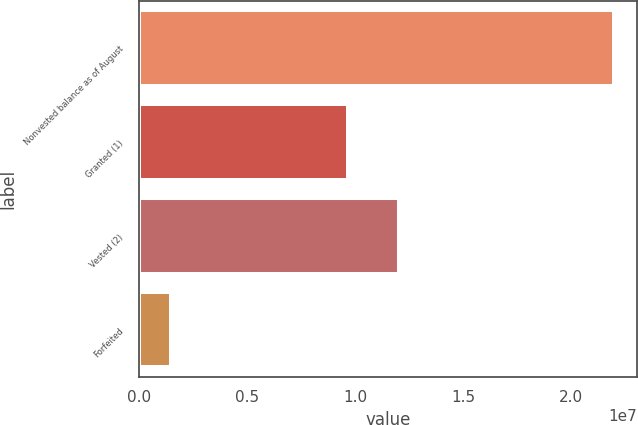Convert chart. <chart><loc_0><loc_0><loc_500><loc_500><bar_chart><fcel>Nonvested balance as of August<fcel>Granted (1)<fcel>Vested (2)<fcel>Forfeited<nl><fcel>2.19637e+07<fcel>9.69969e+06<fcel>1.20249e+07<fcel>1.48158e+06<nl></chart> 